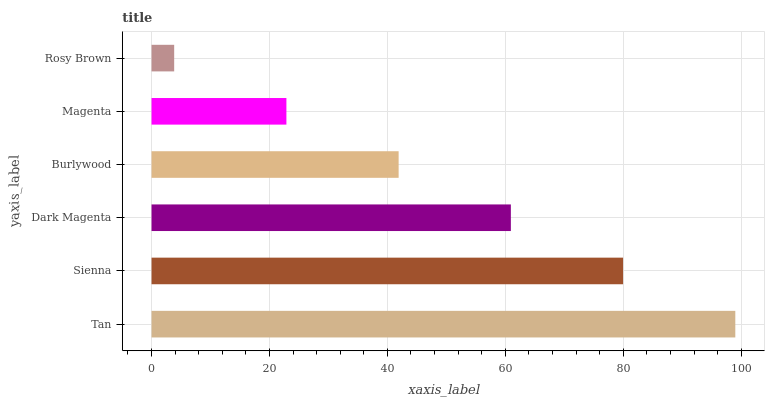Is Rosy Brown the minimum?
Answer yes or no. Yes. Is Tan the maximum?
Answer yes or no. Yes. Is Sienna the minimum?
Answer yes or no. No. Is Sienna the maximum?
Answer yes or no. No. Is Tan greater than Sienna?
Answer yes or no. Yes. Is Sienna less than Tan?
Answer yes or no. Yes. Is Sienna greater than Tan?
Answer yes or no. No. Is Tan less than Sienna?
Answer yes or no. No. Is Dark Magenta the high median?
Answer yes or no. Yes. Is Burlywood the low median?
Answer yes or no. Yes. Is Magenta the high median?
Answer yes or no. No. Is Dark Magenta the low median?
Answer yes or no. No. 